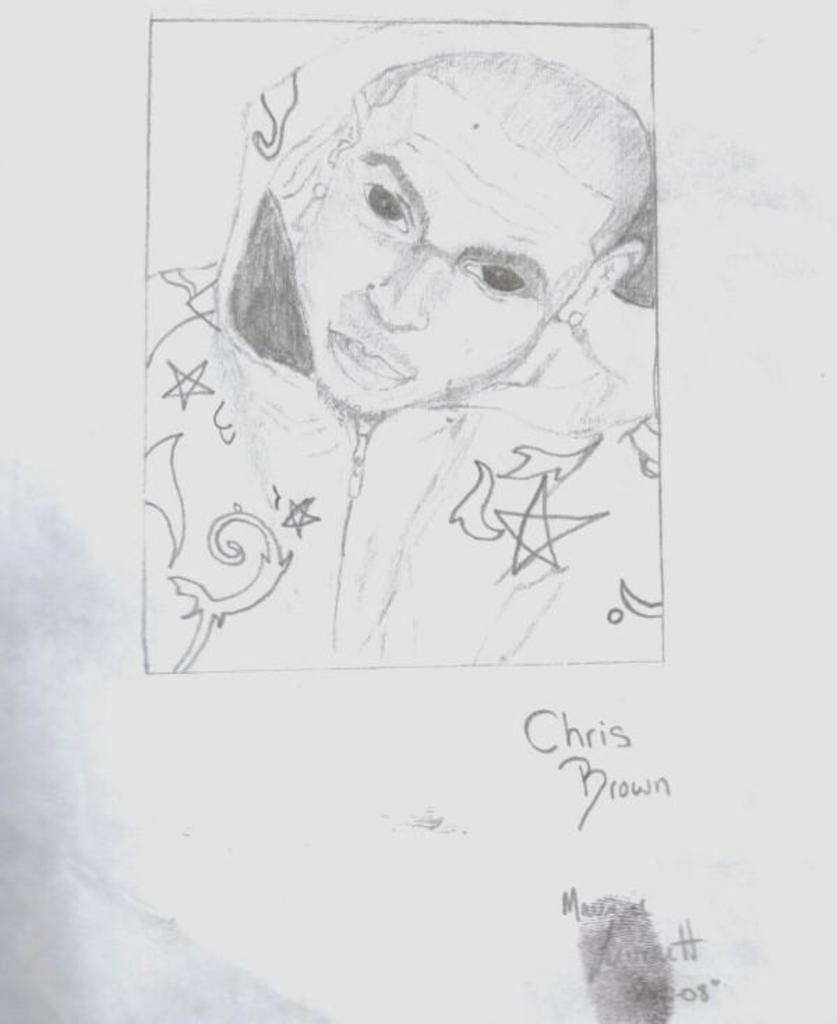What is depicted on the paper in the image? There is a sketch drawn on a paper in the image. Can you describe the paper with the sketch? The paper with the sketch is present in the image. What type of window is depicted in the sketch? There is no window depicted in the sketch, as the facts only mention the sketch on a paper. 